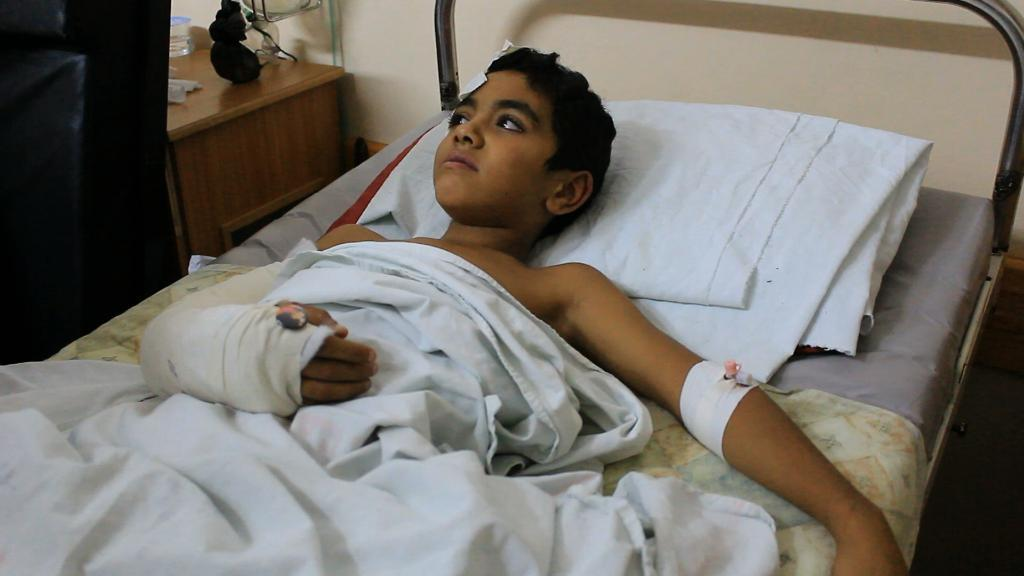Who is the main subject in the image? There is a boy in the center of the image. What is the boy doing in the image? The boy is sleeping on a bed. Can you describe the boy's condition in the image? The boy appears to be injured. What is located beside the bed in the image? There is a table beside the bed. What can be found on the table in the image? There are objects on the table. What type of dinner is being served on the stage in the image? There is no dinner or stage present in the image; it features a boy sleeping on a bed with a table beside it. What color are the boy's eyes in the image? The boy's eyes are not visible in the image, as he is sleeping with his face turned away from the camera. 